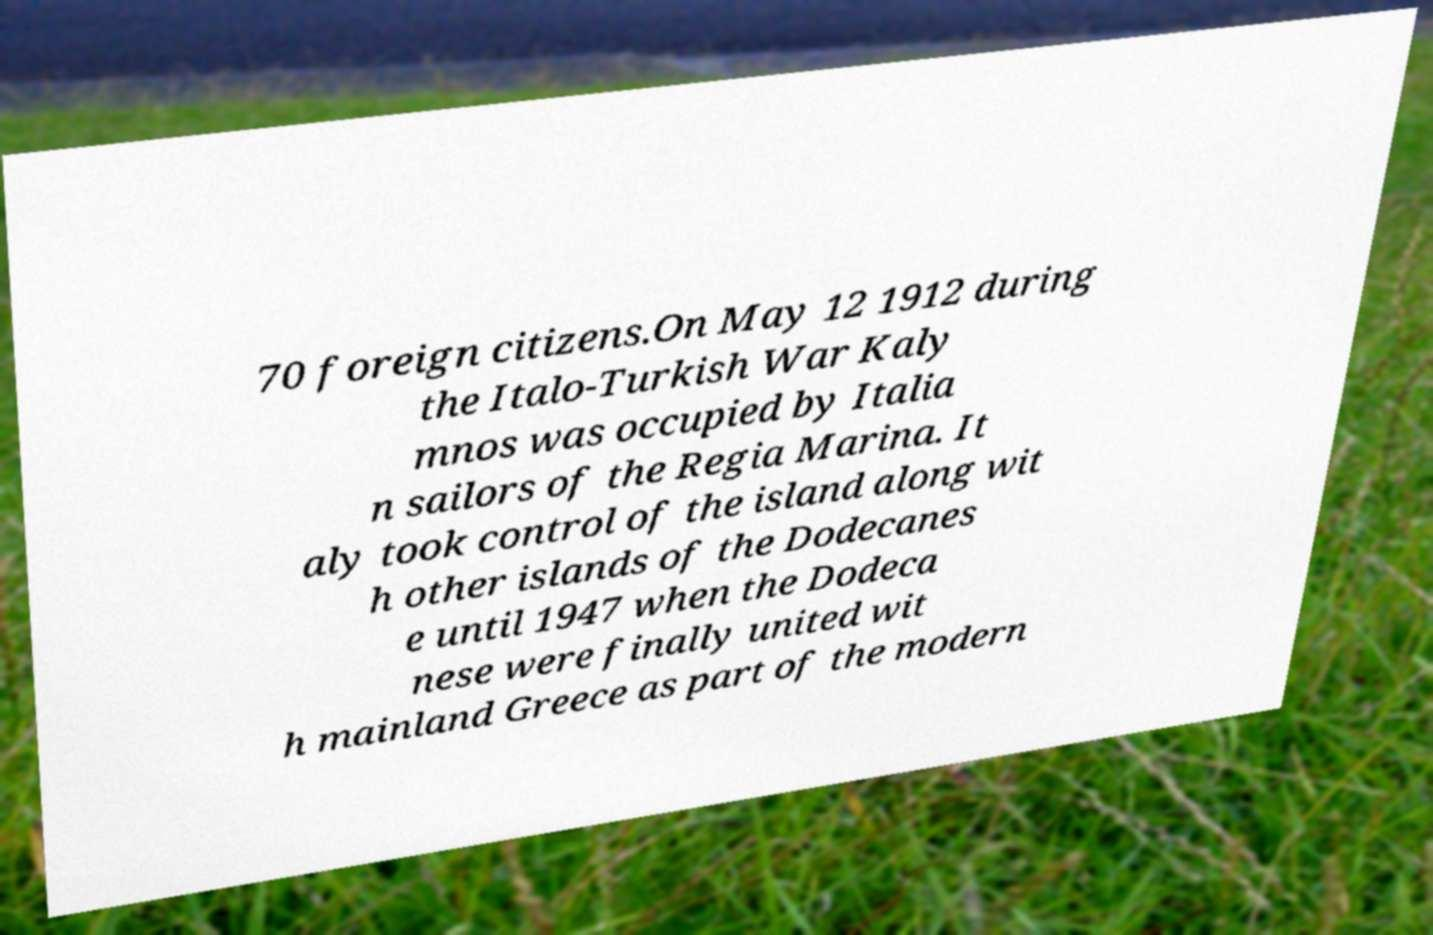What messages or text are displayed in this image? I need them in a readable, typed format. 70 foreign citizens.On May 12 1912 during the Italo-Turkish War Kaly mnos was occupied by Italia n sailors of the Regia Marina. It aly took control of the island along wit h other islands of the Dodecanes e until 1947 when the Dodeca nese were finally united wit h mainland Greece as part of the modern 